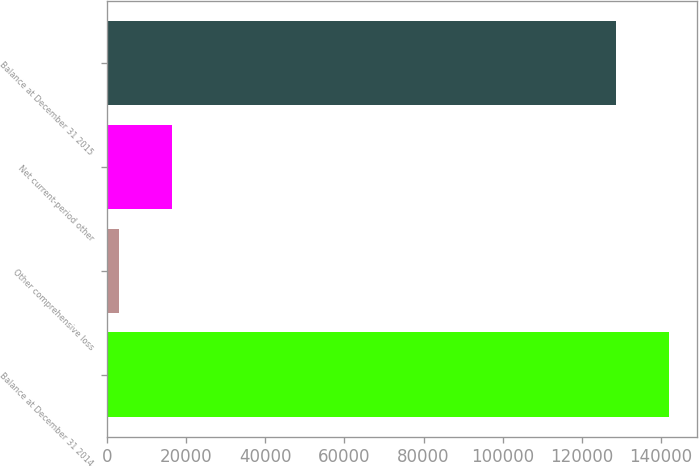Convert chart to OTSL. <chart><loc_0><loc_0><loc_500><loc_500><bar_chart><fcel>Balance at December 31 2014<fcel>Other comprehensive loss<fcel>Net current-period other<fcel>Balance at December 31 2015<nl><fcel>141901<fcel>3130<fcel>16436.8<fcel>128594<nl></chart> 